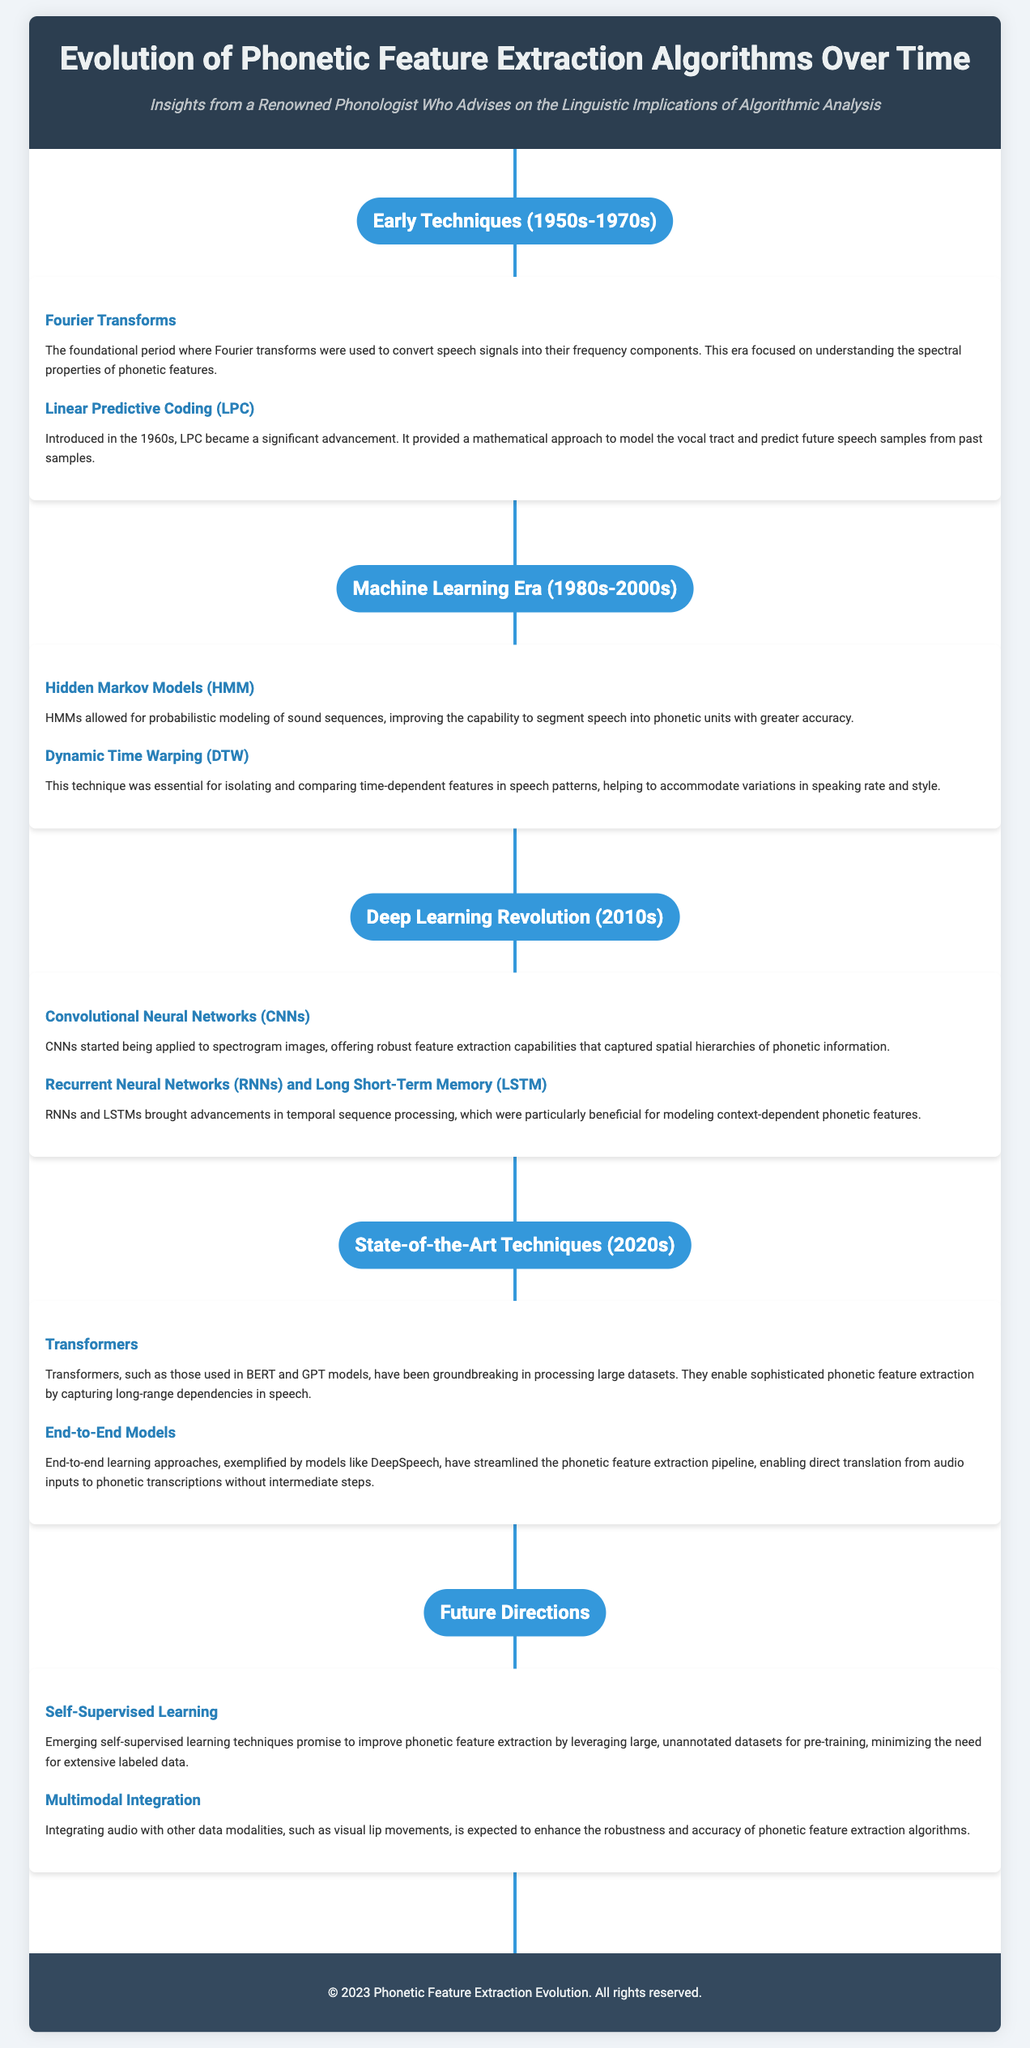What era is associated with Fourier Transforms? The document explicitly states that Fourier Transforms were used during the Early Techniques era, which spanned from the 1950s to the 1970s.
Answer: Early Techniques (1950s-1970s) What technique introduced in the 1960s provided a mathematical approach to model the vocal tract? The document identifies Linear Predictive Coding (LPC) as the significant advancement introduced in the 1960s that modeled the vocal tract.
Answer: Linear Predictive Coding (LPC) Which techniques were highlighted during the Deep Learning Revolution? The document lists Convolutional Neural Networks (CNNs) and Recurrent Neural Networks (RNNs) and Long Short-Term Memory (LSTM) as key techniques from this era.
Answer: Convolutional Neural Networks (CNNs) and Recurrent Neural Networks (RNNs) and Long Short-Term Memory (LSTM) What major advancement do Transformers provide in phonetic feature extraction? Transformers, such as those used in BERT and GPT models, enable sophisticated phonetic feature extraction by capturing long-range dependencies in speech.
Answer: Capturing long-range dependencies What future direction involves improving phonetic feature extraction with unannotated datasets? The document suggests that Self-Supervised Learning techniques will improve phonetic feature extraction by leveraging large, unannotated datasets.
Answer: Self-Supervised Learning How many sections are there in the timeline of phonetic feature extraction algorithms? The document outlines five sections, each detailing different eras and techniques in phonetic feature extraction.
Answer: Five sections 